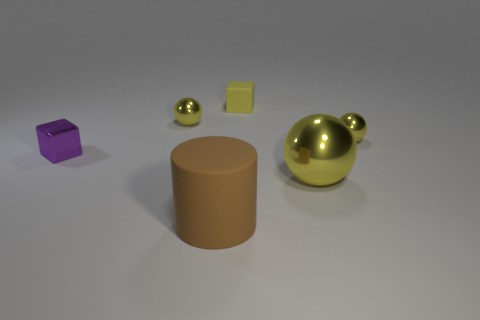Subtract all yellow spheres. How many were subtracted if there are1yellow spheres left? 2 Add 1 small metallic balls. How many objects exist? 7 Subtract all cylinders. How many objects are left? 5 Subtract all tiny metal cubes. Subtract all tiny yellow matte objects. How many objects are left? 4 Add 2 small yellow spheres. How many small yellow spheres are left? 4 Add 6 yellow rubber cubes. How many yellow rubber cubes exist? 7 Subtract 0 blue cylinders. How many objects are left? 6 